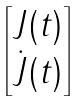Convert formula to latex. <formula><loc_0><loc_0><loc_500><loc_500>\begin{bmatrix} J ( t ) \\ \dot { J } ( t ) \end{bmatrix}</formula> 